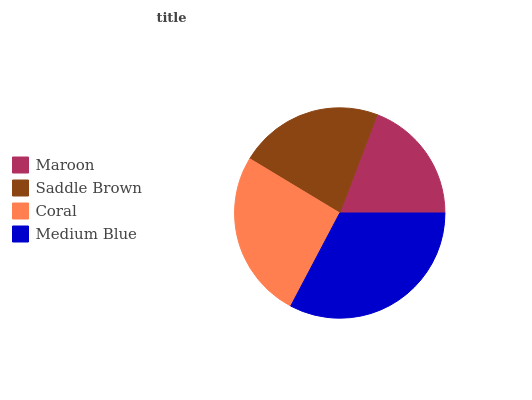Is Maroon the minimum?
Answer yes or no. Yes. Is Medium Blue the maximum?
Answer yes or no. Yes. Is Saddle Brown the minimum?
Answer yes or no. No. Is Saddle Brown the maximum?
Answer yes or no. No. Is Saddle Brown greater than Maroon?
Answer yes or no. Yes. Is Maroon less than Saddle Brown?
Answer yes or no. Yes. Is Maroon greater than Saddle Brown?
Answer yes or no. No. Is Saddle Brown less than Maroon?
Answer yes or no. No. Is Coral the high median?
Answer yes or no. Yes. Is Saddle Brown the low median?
Answer yes or no. Yes. Is Maroon the high median?
Answer yes or no. No. Is Maroon the low median?
Answer yes or no. No. 